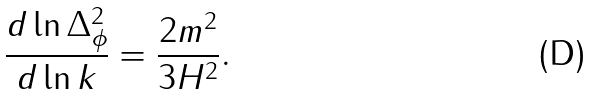Convert formula to latex. <formula><loc_0><loc_0><loc_500><loc_500>\frac { d \ln \Delta ^ { 2 } _ { \phi } } { d \ln k } = \frac { 2 m ^ { 2 } } { 3 H ^ { 2 } } .</formula> 